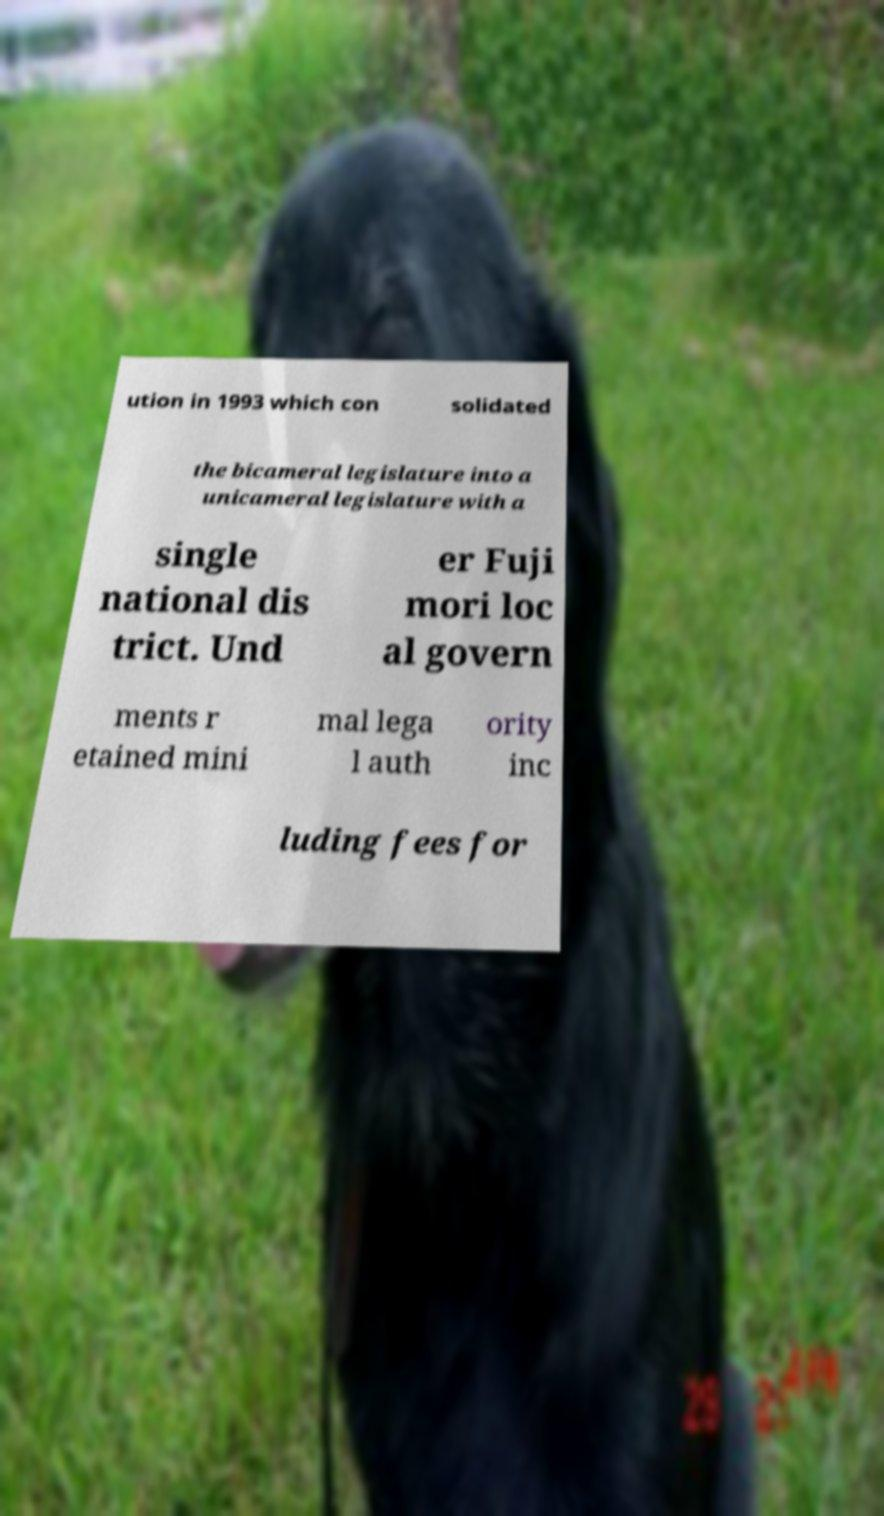Can you read and provide the text displayed in the image?This photo seems to have some interesting text. Can you extract and type it out for me? ution in 1993 which con solidated the bicameral legislature into a unicameral legislature with a single national dis trict. Und er Fuji mori loc al govern ments r etained mini mal lega l auth ority inc luding fees for 